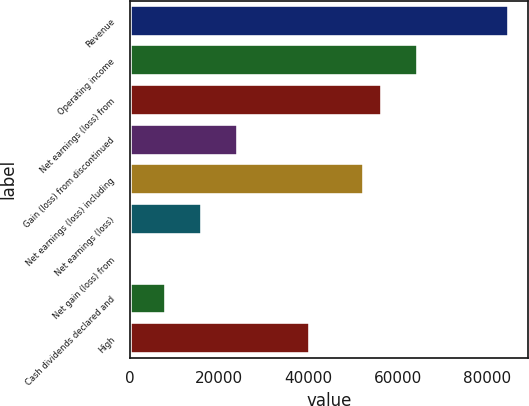Convert chart to OTSL. <chart><loc_0><loc_0><loc_500><loc_500><bar_chart><fcel>Revenue<fcel>Operating income<fcel>Net earnings (loss) from<fcel>Gain (loss) from discontinued<fcel>Net earnings (loss) including<fcel>Net earnings (loss)<fcel>Net gain (loss) from<fcel>Cash dividends declared and<fcel>High<nl><fcel>84711.9<fcel>64542.4<fcel>56474.6<fcel>24203.4<fcel>52440.7<fcel>16135.6<fcel>0.04<fcel>8067.84<fcel>40339<nl></chart> 